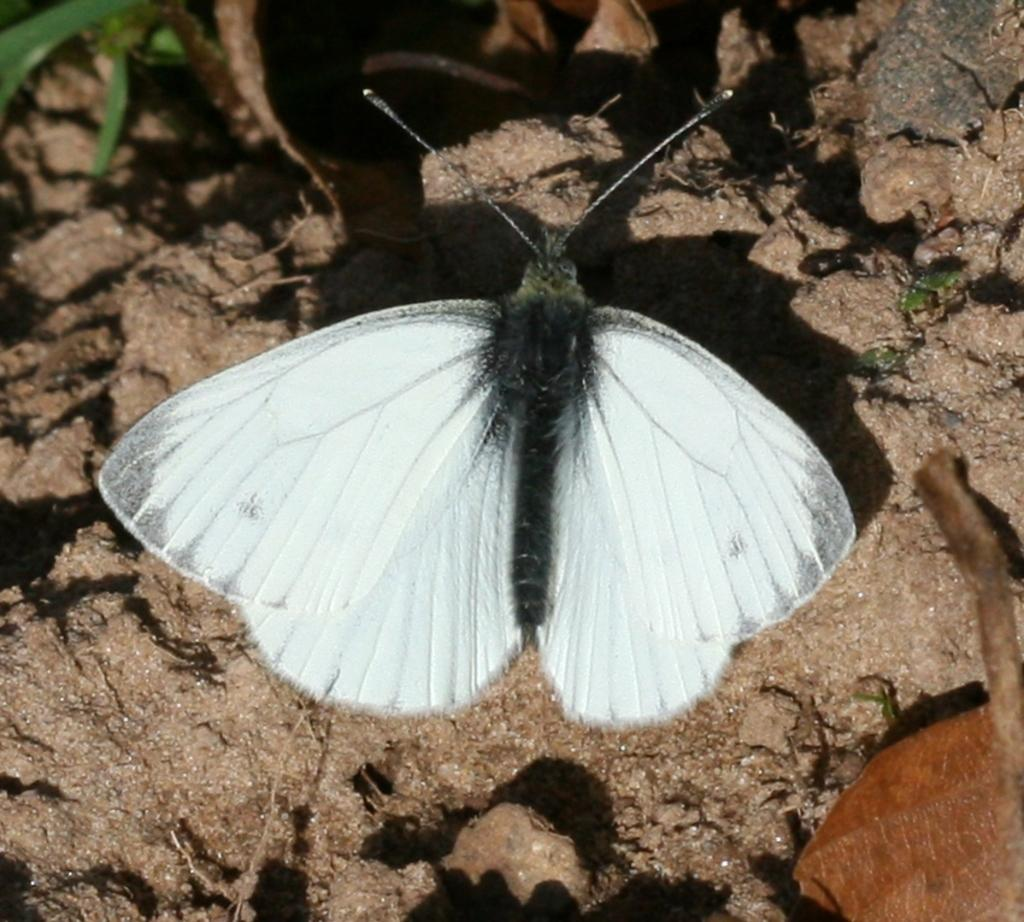What type of insect is present in the image? The image contains a fly. What color is the fly in the image? The fly is in black and white color. Where is the fly located in the image? The fly is on the floor. What type of surface is the fly on? There is sand and stones on the floor. What type of straw is the fly using to build a nest in the image? There is no straw present in the image, and the fly is not building a nest. 